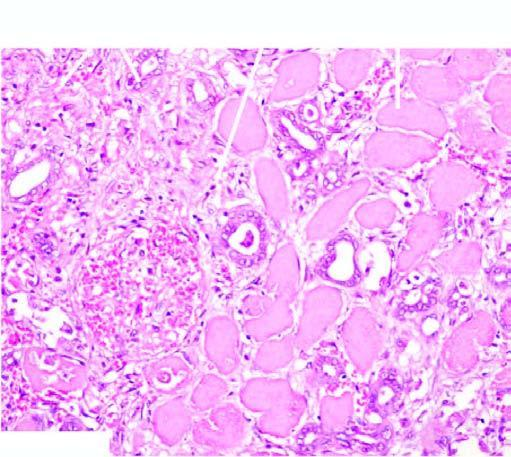do renal tubules and glomeruli show typical coagulative necrosis?
Answer the question using a single word or phrase. Yes 